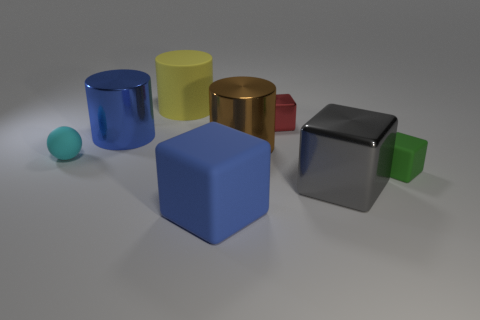Are the tiny block that is in front of the big brown shiny cylinder and the large block behind the large blue cube made of the same material?
Offer a terse response. No. There is a object that is behind the cube that is behind the brown cylinder; is there a gray block behind it?
Provide a succinct answer. No. There is a big rubber object in front of the big rubber cylinder; is it the same color as the large metal object on the left side of the big brown shiny object?
Provide a short and direct response. Yes. What material is the cyan thing that is the same size as the red block?
Provide a succinct answer. Rubber. There is a rubber object that is left of the large blue object behind the cylinder to the right of the big matte cube; what size is it?
Give a very brief answer. Small. How many other things are there of the same material as the yellow thing?
Make the answer very short. 3. There is a rubber block that is right of the small red metallic thing; how big is it?
Ensure brevity in your answer.  Small. What number of matte things are left of the tiny metal object and in front of the tiny cyan object?
Provide a short and direct response. 1. What material is the tiny object that is right of the metallic thing that is in front of the small sphere?
Your response must be concise. Rubber. There is a large gray thing that is the same shape as the green matte object; what is its material?
Provide a short and direct response. Metal. 